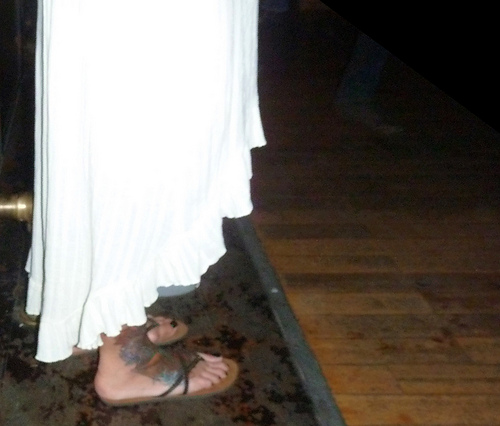<image>
Is there a dress on the floor? No. The dress is not positioned on the floor. They may be near each other, but the dress is not supported by or resting on top of the floor. 